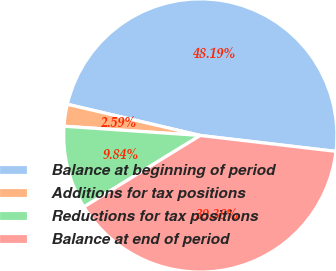Convert chart to OTSL. <chart><loc_0><loc_0><loc_500><loc_500><pie_chart><fcel>Balance at beginning of period<fcel>Additions for tax positions<fcel>Reductions for tax positions<fcel>Balance at end of period<nl><fcel>48.19%<fcel>2.59%<fcel>9.84%<fcel>39.38%<nl></chart> 